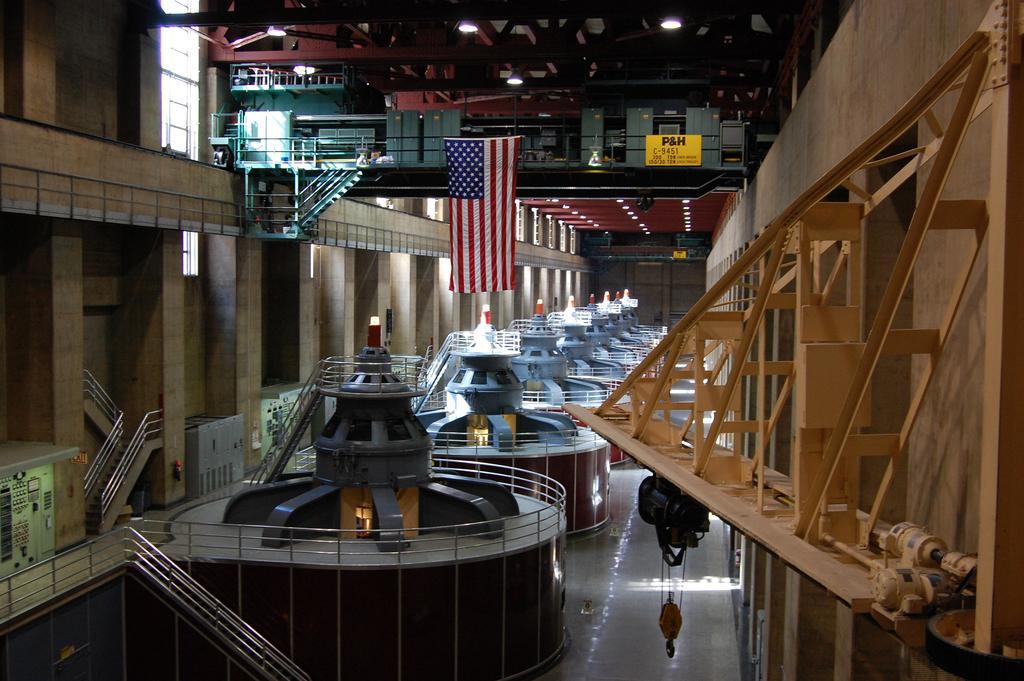Can you describe this image briefly? The picture looks like it is taken inside a factory. In this picture we can see a round shaped object with railing and other things. On the right we can see wall and a machine. In the middle we can see flag, machine and light. On the left there are windows, wall, staircase and other objects. At the bottom there is floor. 